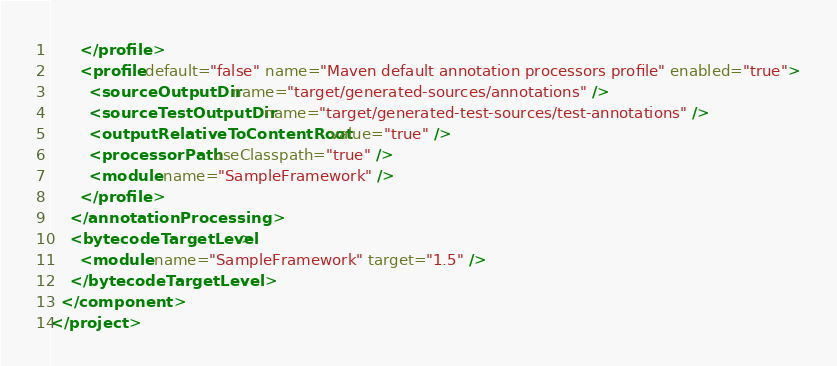Convert code to text. <code><loc_0><loc_0><loc_500><loc_500><_XML_>      </profile>
      <profile default="false" name="Maven default annotation processors profile" enabled="true">
        <sourceOutputDir name="target/generated-sources/annotations" />
        <sourceTestOutputDir name="target/generated-test-sources/test-annotations" />
        <outputRelativeToContentRoot value="true" />
        <processorPath useClasspath="true" />
        <module name="SampleFramework" />
      </profile>
    </annotationProcessing>
    <bytecodeTargetLevel>
      <module name="SampleFramework" target="1.5" />
    </bytecodeTargetLevel>
  </component>
</project></code> 